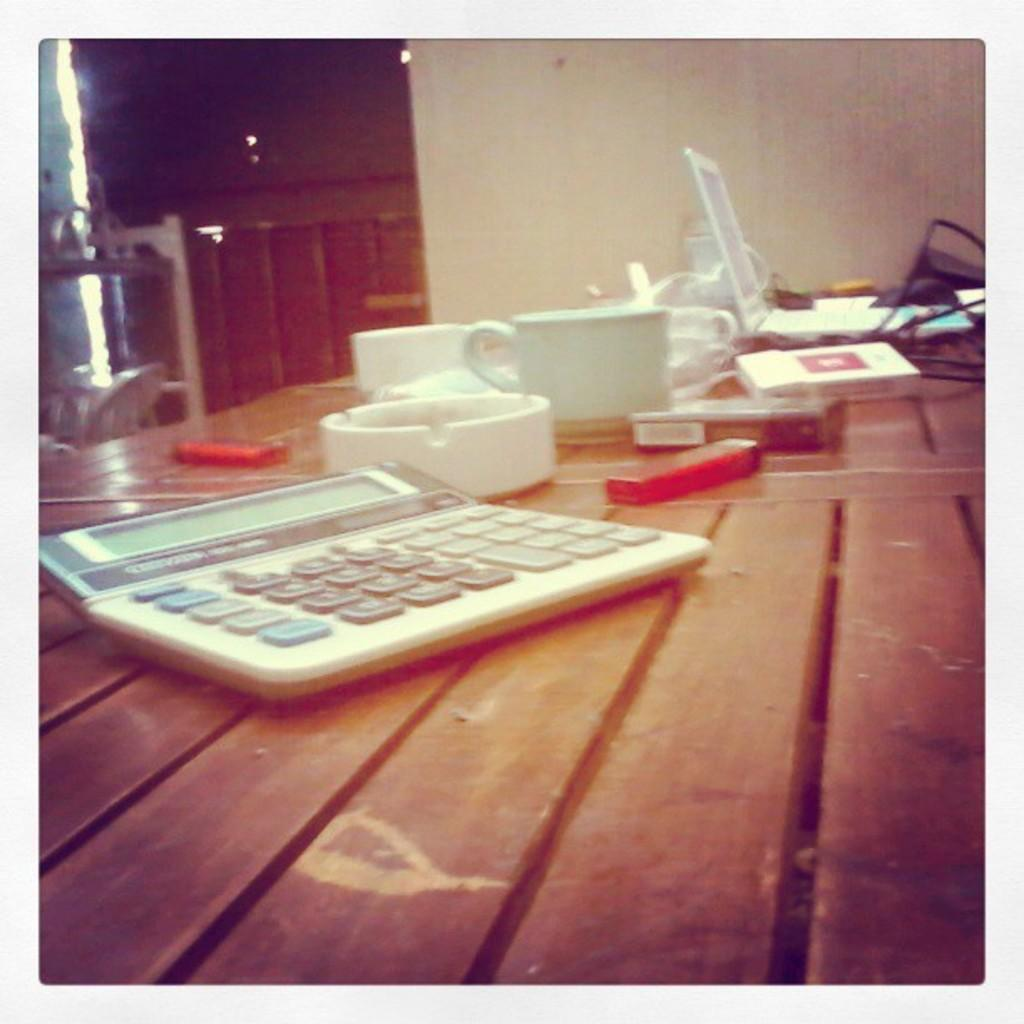What piece of furniture is in the image? There is a table in the image. What electronic device is on the table? A calculator and a laptop are present on the table. What type of container is visible on the table? There is a cup visible on the table. What type of animal is the farmer holding by the tail in the image? There is no farmer or animal present in the image; it only features a table with a calculator, laptop, and cup. 